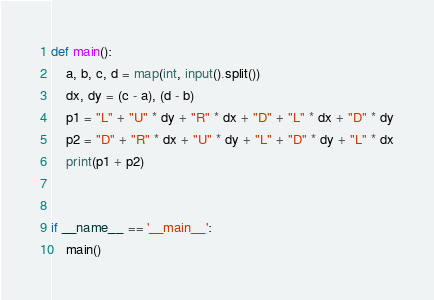<code> <loc_0><loc_0><loc_500><loc_500><_Python_>def main():
    a, b, c, d = map(int, input().split())
    dx, dy = (c - a), (d - b)
    p1 = "L" + "U" * dy + "R" * dx + "D" + "L" * dx + "D" * dy
    p2 = "D" + "R" * dx + "U" * dy + "L" + "D" * dy + "L" * dx
    print(p1 + p2)


if __name__ == '__main__':
    main()
</code> 